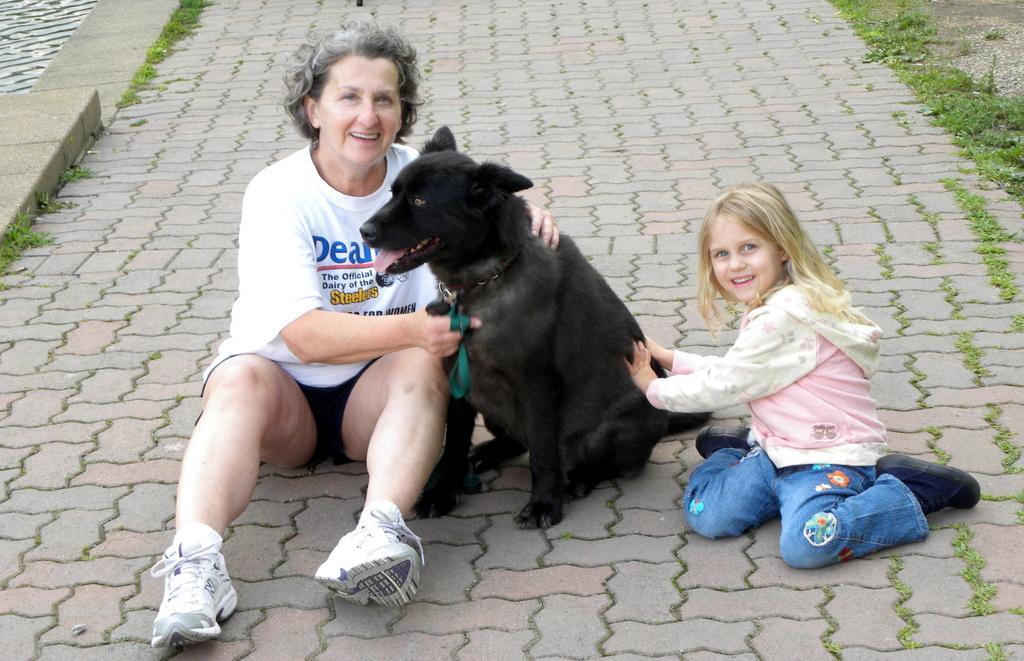Can you describe this image briefly? This picture shows a woman and a girl seated holding a dog in the middle on a sidewalk 